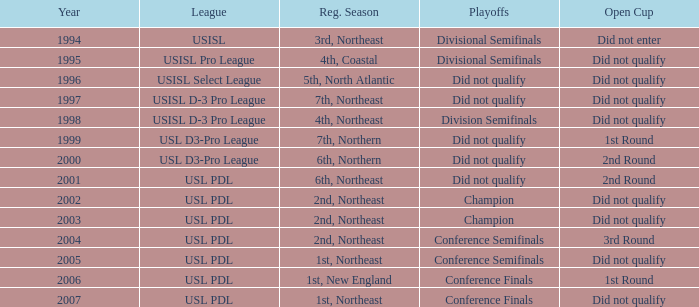Would you be able to parse every entry in this table? {'header': ['Year', 'League', 'Reg. Season', 'Playoffs', 'Open Cup'], 'rows': [['1994', 'USISL', '3rd, Northeast', 'Divisional Semifinals', 'Did not enter'], ['1995', 'USISL Pro League', '4th, Coastal', 'Divisional Semifinals', 'Did not qualify'], ['1996', 'USISL Select League', '5th, North Atlantic', 'Did not qualify', 'Did not qualify'], ['1997', 'USISL D-3 Pro League', '7th, Northeast', 'Did not qualify', 'Did not qualify'], ['1998', 'USISL D-3 Pro League', '4th, Northeast', 'Division Semifinals', 'Did not qualify'], ['1999', 'USL D3-Pro League', '7th, Northern', 'Did not qualify', '1st Round'], ['2000', 'USL D3-Pro League', '6th, Northern', 'Did not qualify', '2nd Round'], ['2001', 'USL PDL', '6th, Northeast', 'Did not qualify', '2nd Round'], ['2002', 'USL PDL', '2nd, Northeast', 'Champion', 'Did not qualify'], ['2003', 'USL PDL', '2nd, Northeast', 'Champion', 'Did not qualify'], ['2004', 'USL PDL', '2nd, Northeast', 'Conference Semifinals', '3rd Round'], ['2005', 'USL PDL', '1st, Northeast', 'Conference Semifinals', 'Did not qualify'], ['2006', 'USL PDL', '1st, New England', 'Conference Finals', '1st Round'], ['2007', 'USL PDL', '1st, Northeast', 'Conference Finals', 'Did not qualify']]} Identify the postseason games for usisl select league. Did not qualify. 